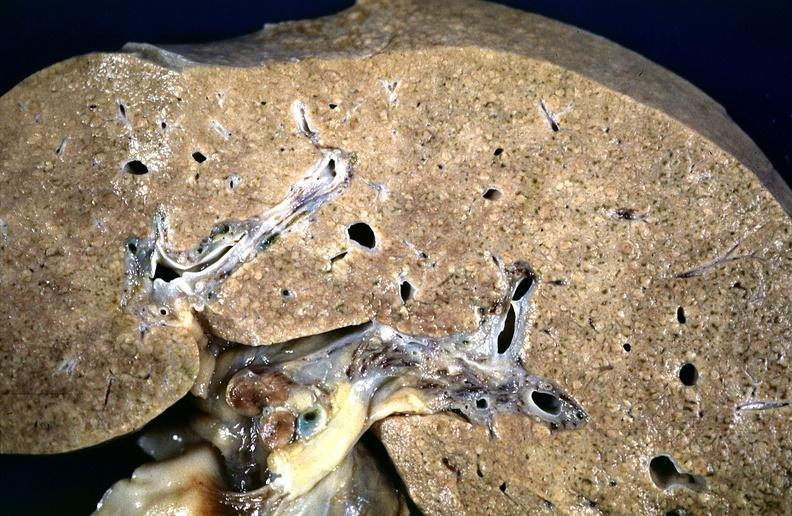does this image show cirrhosis?
Answer the question using a single word or phrase. Yes 